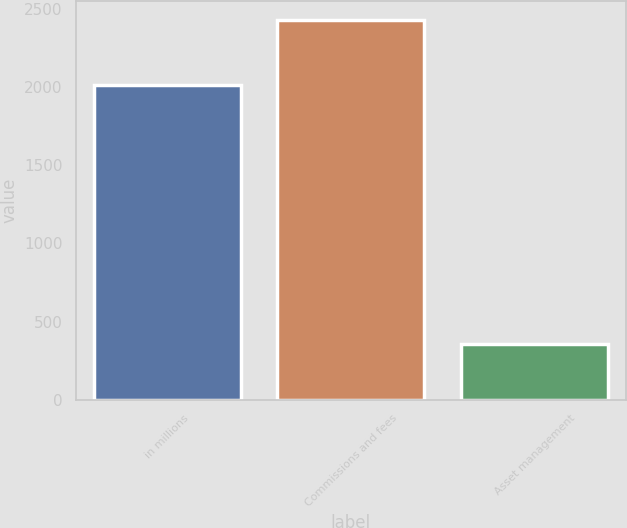Convert chart. <chart><loc_0><loc_0><loc_500><loc_500><bar_chart><fcel>in millions<fcel>Commissions and fees<fcel>Asset management<nl><fcel>2017<fcel>2433<fcel>359<nl></chart> 